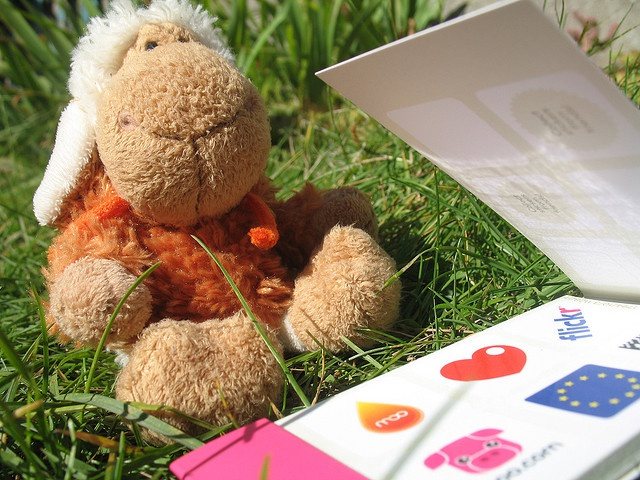Describe the objects in this image and their specific colors. I can see a book in darkgreen, white, darkgray, gray, and violet tones in this image. 